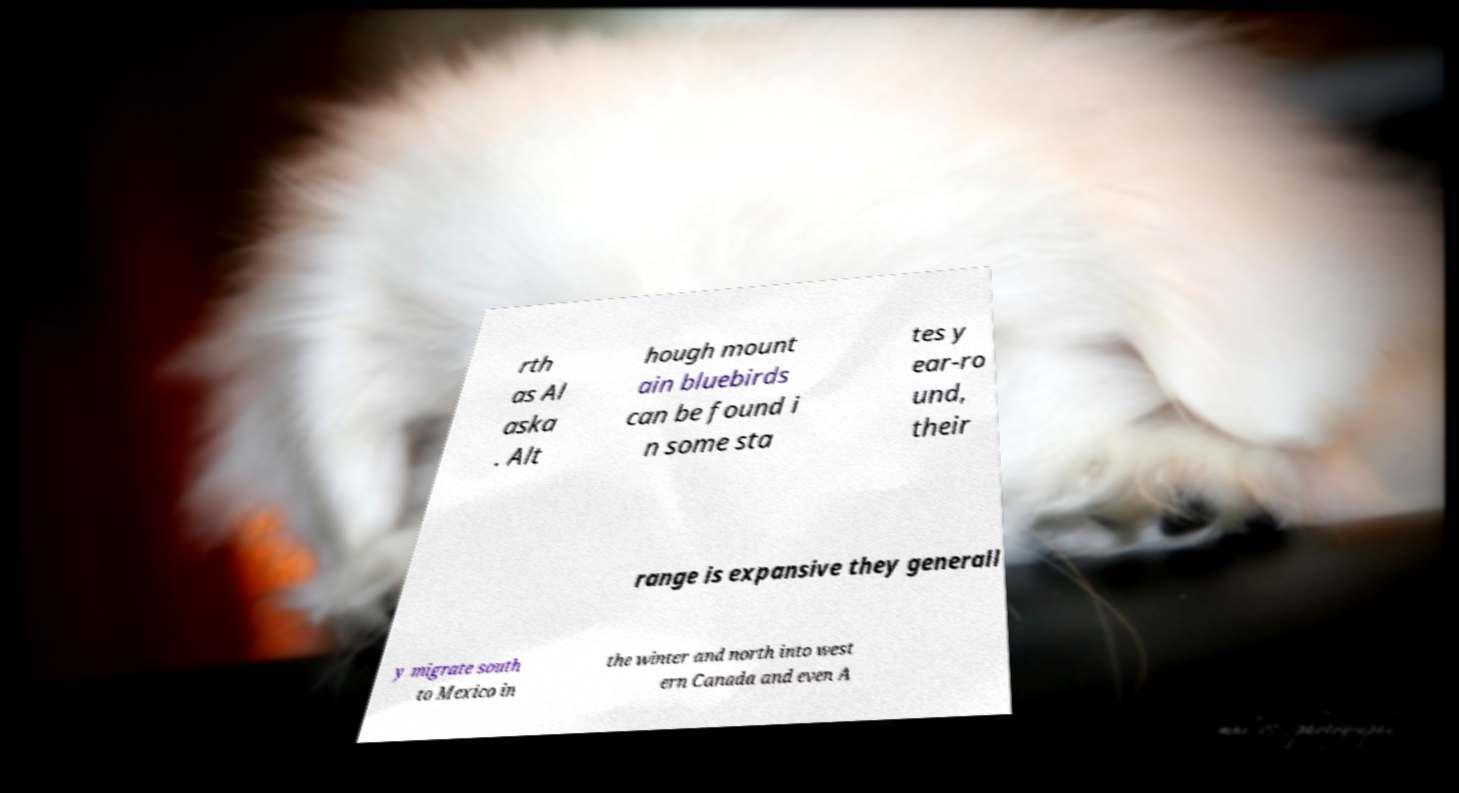Could you extract and type out the text from this image? rth as Al aska . Alt hough mount ain bluebirds can be found i n some sta tes y ear-ro und, their range is expansive they generall y migrate south to Mexico in the winter and north into west ern Canada and even A 